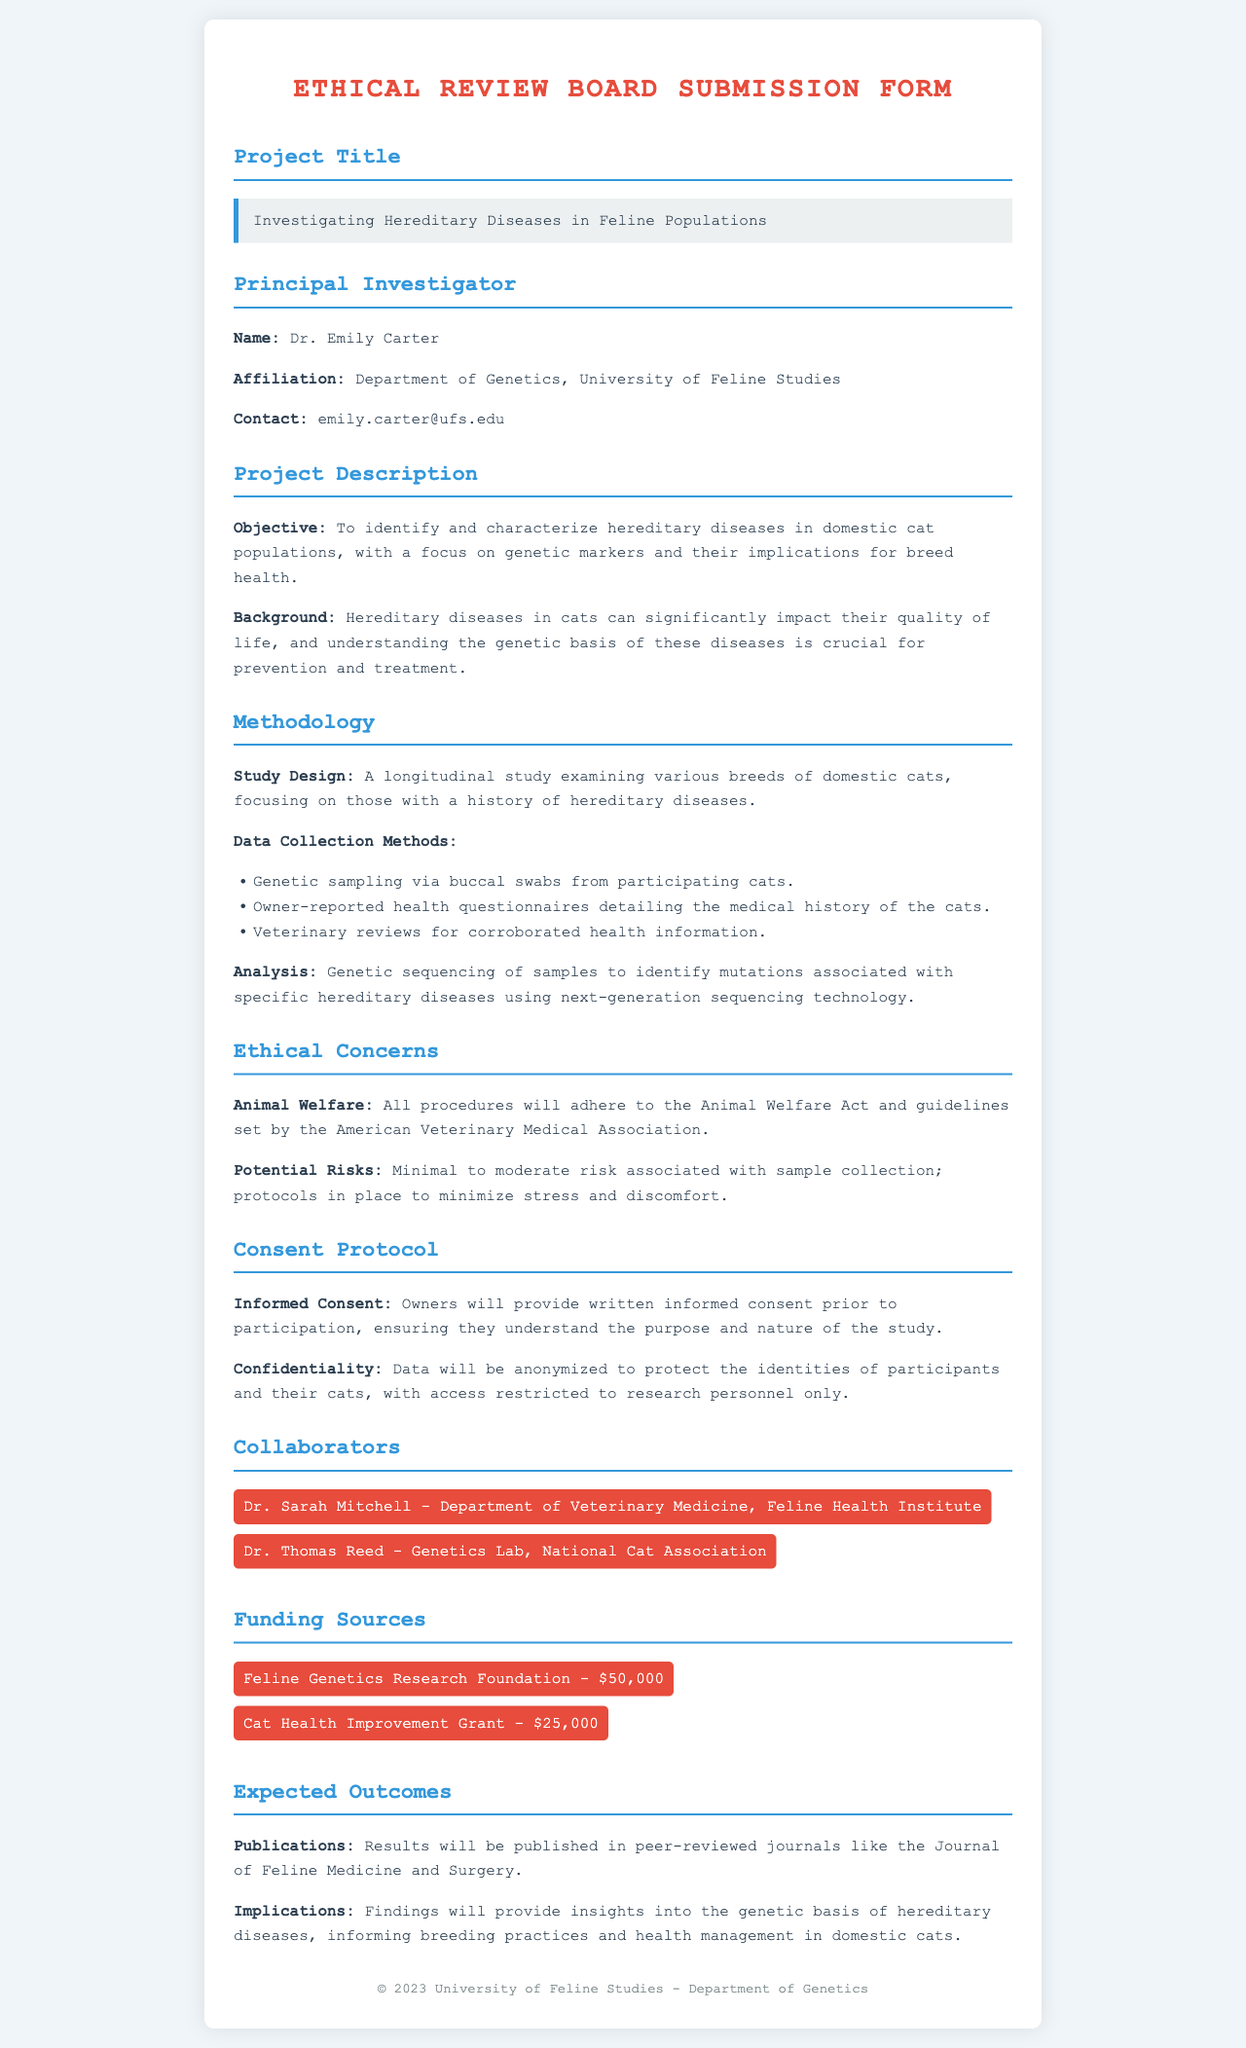What is the project title? The project title is prominently displayed in the document and is "Investigating Hereditary Diseases in Feline Populations."
Answer: Investigating Hereditary Diseases in Feline Populations Who is the principal investigator? The document identifies the principal investigator as Dr. Emily Carter.
Answer: Dr. Emily Carter What is the funding amount from the Feline Genetics Research Foundation? The document specifies the funding amount as $50,000 from the Feline Genetics Research Foundation.
Answer: $50,000 What method will be used for genetic sampling? The document describes using buccal swabs as the method for genetic sampling from participating cats.
Answer: Buccal swabs What ethical consideration is highlighted in the risks section? The document notes that there is minimal to moderate risk associated with sample collection as an ethical concern.
Answer: Minimal to moderate risk How will data confidentiality be maintained? According to the document, data will be anonymized to protect participant identities, with access restricted to research personnel only.
Answer: Data will be anonymized What is the primary objective of the study? The document clearly states that the primary objective is to identify and characterize hereditary diseases in domestic cat populations.
Answer: Identify and characterize hereditary diseases Who are the collaborators listed in the document? The document lists Dr. Sarah Mitchell and Dr. Thomas Reed as collaborators.
Answer: Dr. Sarah Mitchell, Dr. Thomas Reed What is the expected publication outlet for the results? The document mentions that results will be published in the Journal of Feline Medicine and Surgery.
Answer: Journal of Feline Medicine and Surgery 